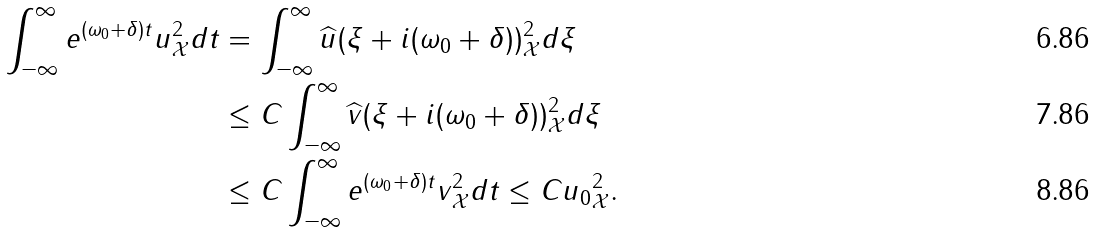<formula> <loc_0><loc_0><loc_500><loc_500>\int _ { - \infty } ^ { \infty } \| e ^ { ( \omega _ { 0 } + \delta ) t } u \| _ { \mathcal { X } } ^ { 2 } d t & = \int _ { - \infty } ^ { \infty } \| \widehat { u } ( \xi + i ( \omega _ { 0 } + \delta ) ) \| _ { \mathcal { X } } ^ { 2 } d \xi \\ & \leq C \int _ { - \infty } ^ { \infty } \| \widehat { v } ( \xi + i ( \omega _ { 0 } + \delta ) ) \| _ { \mathcal { X } } ^ { 2 } d \xi \\ & \leq C \int _ { - \infty } ^ { \infty } \| e ^ { ( \omega _ { 0 } + \delta ) t } v \| _ { \mathcal { X } } ^ { 2 } d t \leq C \| u _ { 0 } \| _ { \mathcal { X } } ^ { 2 } .</formula> 